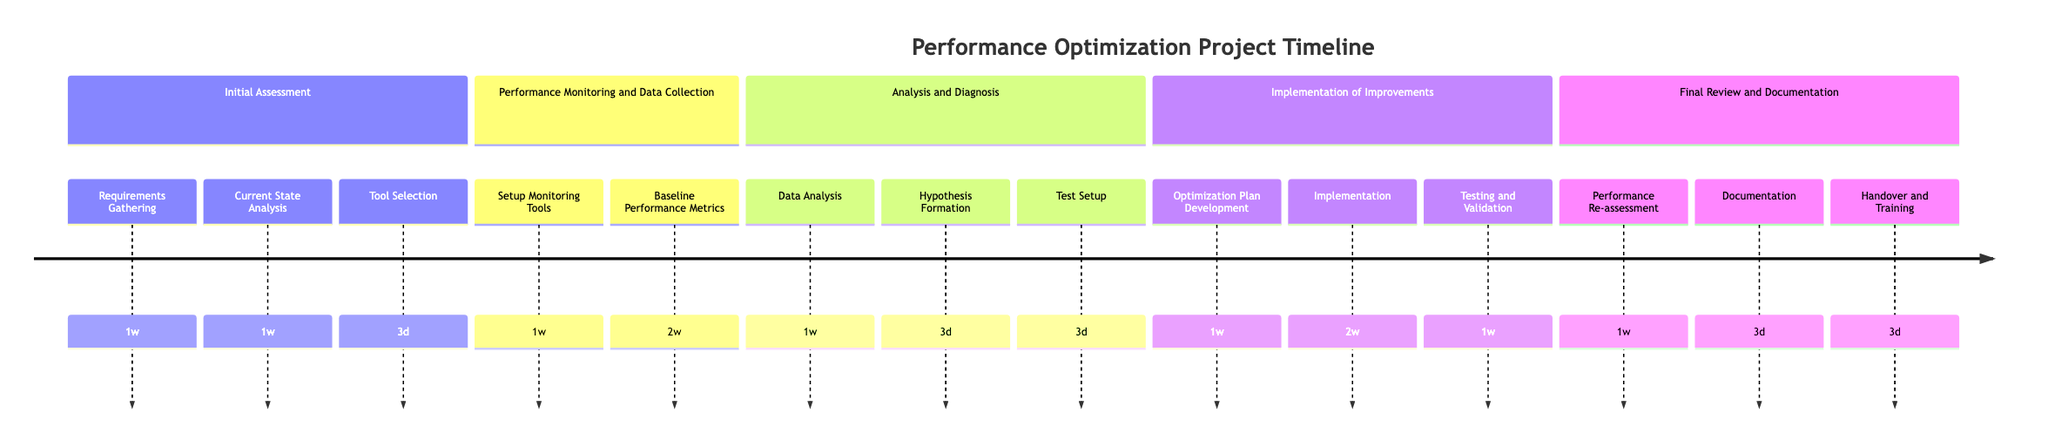What is the total duration of the "Initial Assessment" phase? The "Initial Assessment" phase includes three steps: "Requirements Gathering" (1 week), "Current State Analysis" (1 week), and "Tool Selection" (3 days). Converting all to weeks: 1 week + 1 week + (3 days = 0.429 weeks) = 2.429 weeks.
Answer: Approximately two weeks and three days How many steps are in the "Implementation of Improvements" phase? The "Implementation of Improvements" phase consists of three steps: "Optimization Plan Development," "Implementation," and "Testing and Validation."
Answer: Three steps Which step in the "Final Review and Documentation" phase has the shortest duration? In the "Final Review and Documentation" phase, the steps are "Performance Re-assessment" (1 week), "Documentation" (3 days), and "Handover and Training" (3 days). The shortest duration is associated with both "Documentation" and "Handover and Training," both taking 3 days.
Answer: Documentation and Handover and Training What is the total duration of the "Performance Monitoring and Data Collection" phase? The "Performance Monitoring and Data Collection" phase has two steps: "Setup Monitoring Tools" (1 week) and "Baseline Performance Metrics" (2 weeks). Totaling these durations gives 1 week + 2 weeks = 3 weeks.
Answer: Three weeks Which step follows "Hypothesis Formation" in the "Analysis and Diagnosis" phase? In the "Analysis and Diagnosis" phase, the order of steps is "Data Analysis," then "Hypothesis Formation," followed by "Test Setup." Thus, "Test Setup" directly follows "Hypothesis Formation."
Answer: Test Setup What step occurs before "Testing and Validation" in the "Implementation of Improvements" phase? The steps in the "Implementation of Improvements" phase are in the order of "Optimization Plan Development," then "Implementation," followed by "Testing and Validation." Therefore, "Implementation" occurs before "Testing and Validation."
Answer: Implementation Which phase includes the step "Baseline Performance Metrics"? The "Baseline Performance Metrics" step is part of the "Performance Monitoring and Data Collection" phase, where baseline performance data is collected.
Answer: Performance Monitoring and Data Collection What is the total duration of the "Analysis and Diagnosis" phase? The "Analysis and Diagnosis" phase comprises three steps: "Data Analysis" (1 week), "Hypothesis Formation" (3 days), and "Test Setup" (3 days). Converting everything to weeks: 1 week + (3 days = 0.429 weeks) + (3 days = 0.429 weeks) = 1.858 weeks.
Answer: Approximately one week and six days 